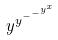Convert formula to latex. <formula><loc_0><loc_0><loc_500><loc_500>y ^ { y ^ { - ^ { - ^ { y ^ { x } } } } }</formula> 